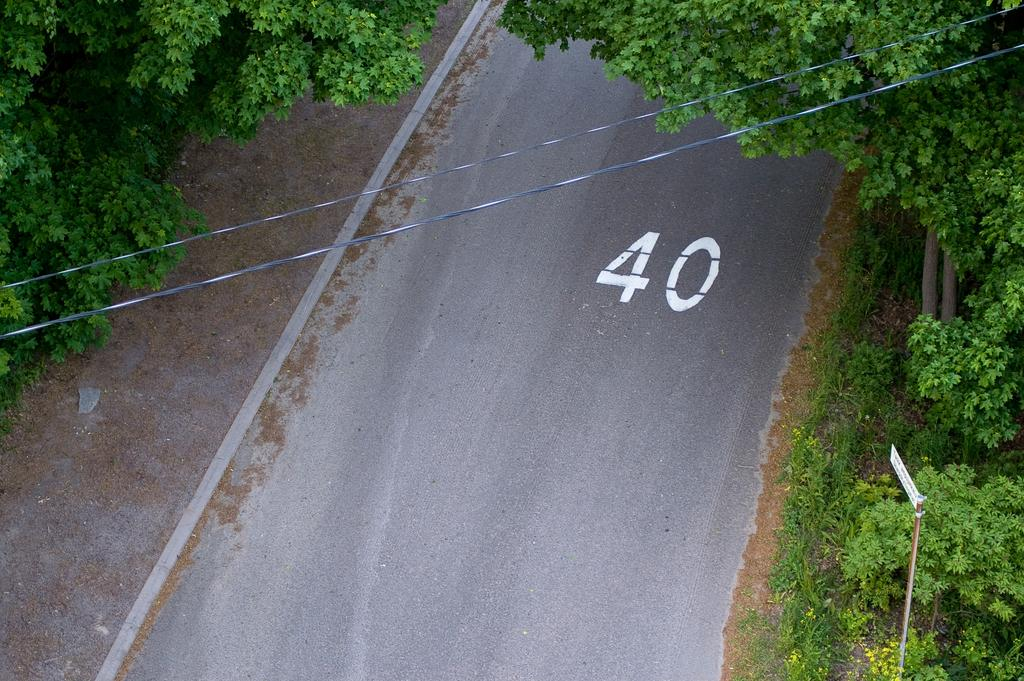What is the main subject of the image? The main subject of the image is a road. What can be seen on both sides of the road? There are trees on both sides of the road. What else is visible in the image? There are wires visible in the image. How does the girl use the grandfather's walking stick in the image? There is no girl or grandfather present in the image, and therefore no such interaction can be observed. 